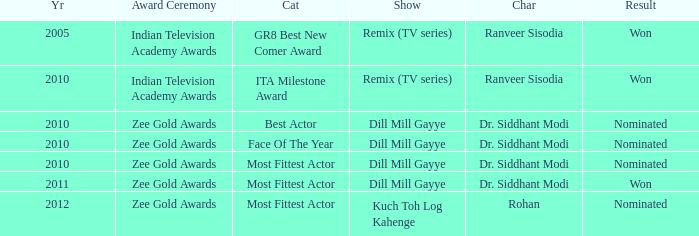Which show has a character of Rohan? Kuch Toh Log Kahenge. 